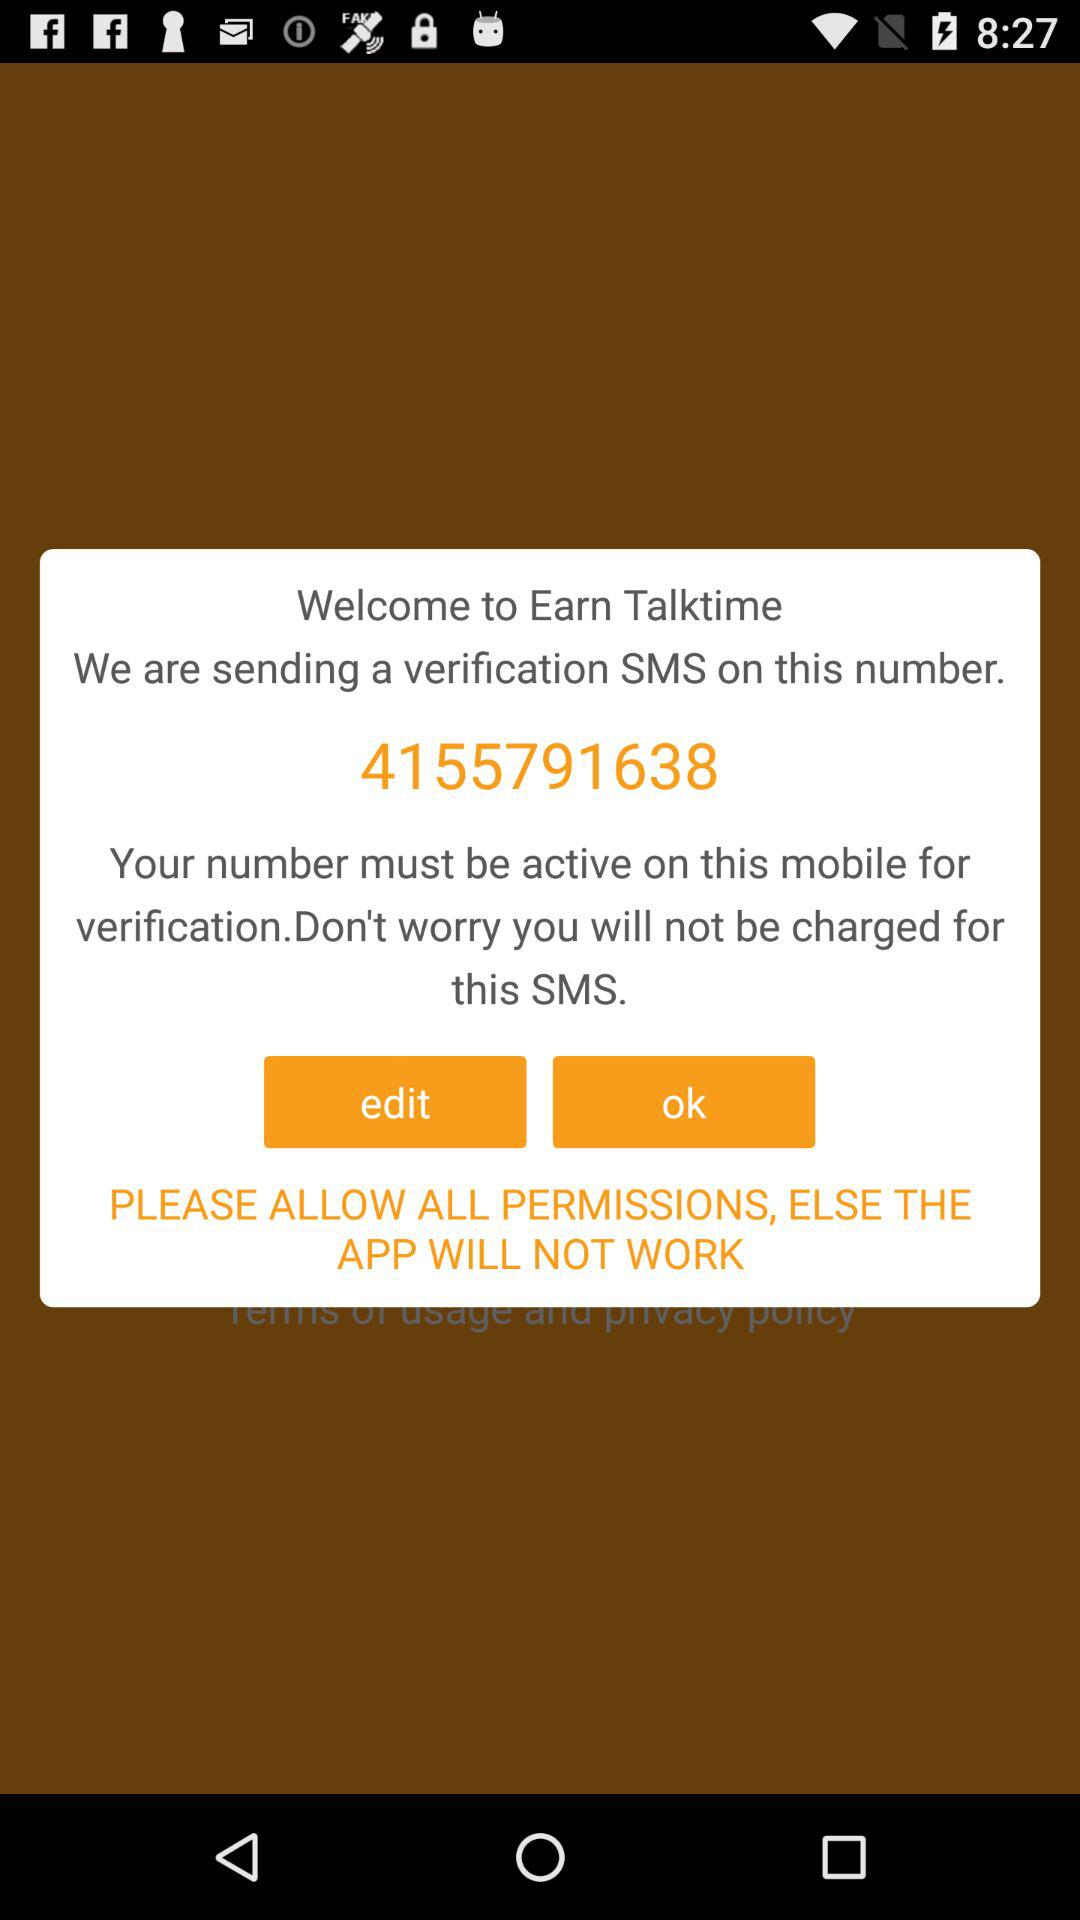What is the phone number to which the verification code is sent? The verification code is sent to 4155791638. 